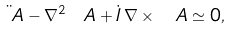<formula> <loc_0><loc_0><loc_500><loc_500>\ddot { \ A } - \nabla ^ { 2 } \ A + \dot { I } \, \nabla \times \ A \simeq 0 ,</formula> 